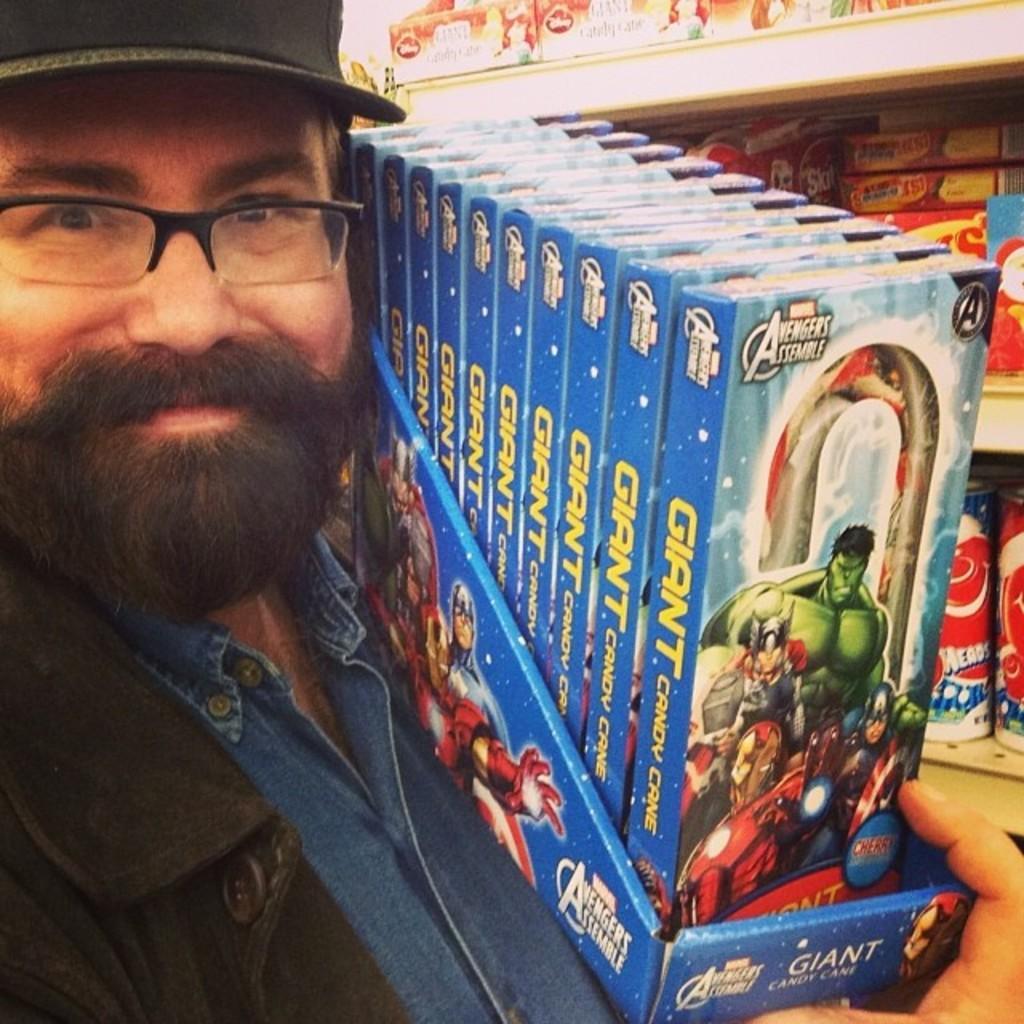Could you give a brief overview of what you see in this image? In this picture I can see a man in front and I see that he is holding a thing, on which there are number of boxes and I see something is written on the boxes and I can see the cartoon character on it. In the background I can see the racks, on which there are number of things. 